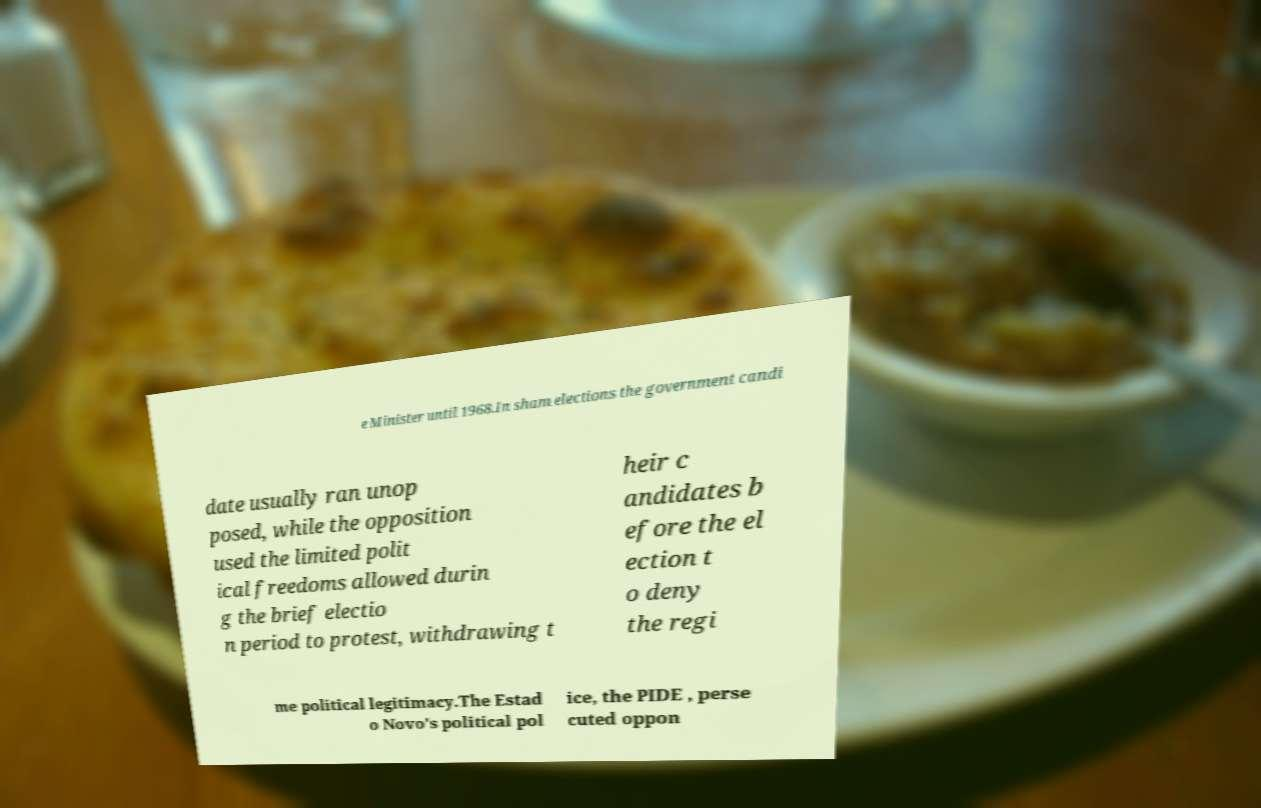For documentation purposes, I need the text within this image transcribed. Could you provide that? e Minister until 1968.In sham elections the government candi date usually ran unop posed, while the opposition used the limited polit ical freedoms allowed durin g the brief electio n period to protest, withdrawing t heir c andidates b efore the el ection t o deny the regi me political legitimacy.The Estad o Novo's political pol ice, the PIDE , perse cuted oppon 